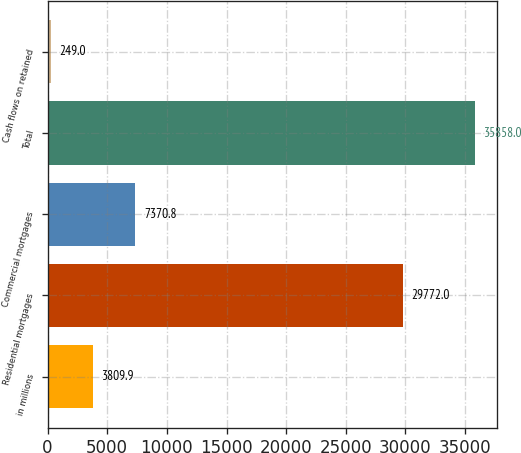<chart> <loc_0><loc_0><loc_500><loc_500><bar_chart><fcel>in millions<fcel>Residential mortgages<fcel>Commercial mortgages<fcel>Total<fcel>Cash flows on retained<nl><fcel>3809.9<fcel>29772<fcel>7370.8<fcel>35858<fcel>249<nl></chart> 